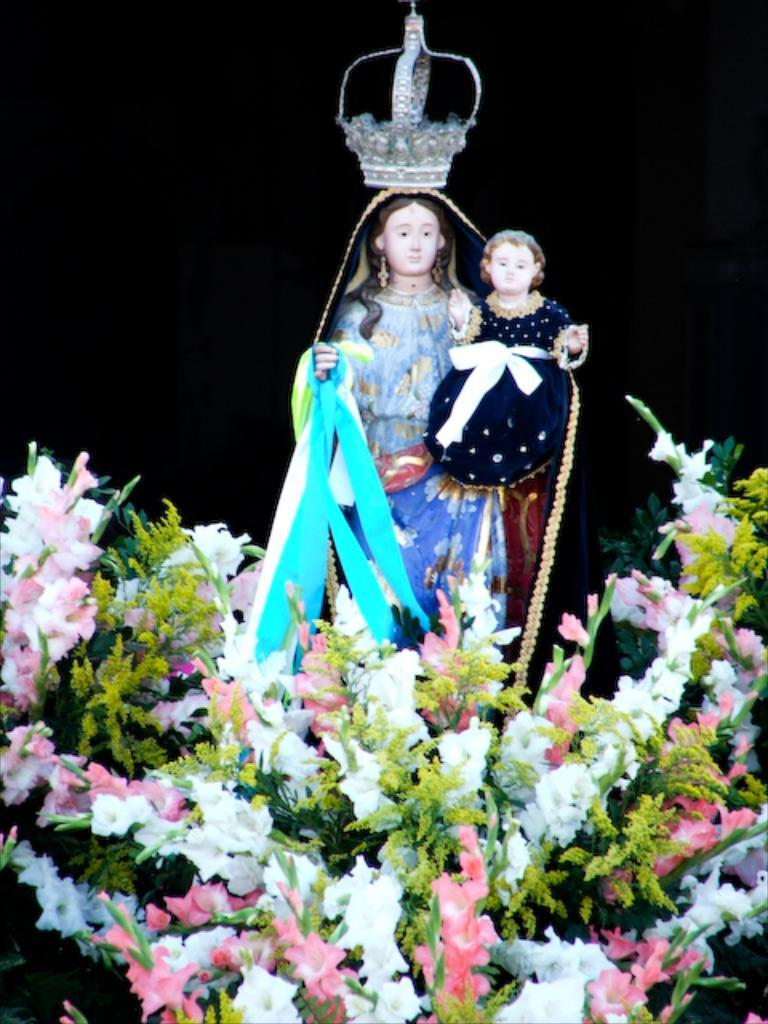What type of living organisms can be seen in the image? There are flowers in the image. What type of dolls are present in the image? There is a doll of a woman and a doll of a girl in the image. How would you describe the overall lighting in the image? The background of the image is dark. What type of arch can be seen in the image? There is no arch present in the image. Who is the friend of the doll of the girl in the image? The image does not show any friends of the dolls, so it cannot be determined from the image. 